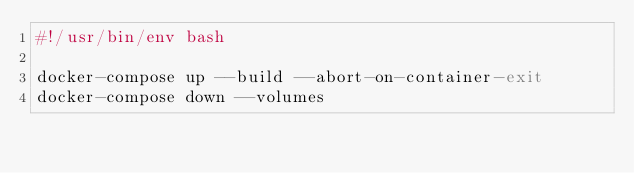<code> <loc_0><loc_0><loc_500><loc_500><_Bash_>#!/usr/bin/env bash

docker-compose up --build --abort-on-container-exit
docker-compose down --volumes
</code> 